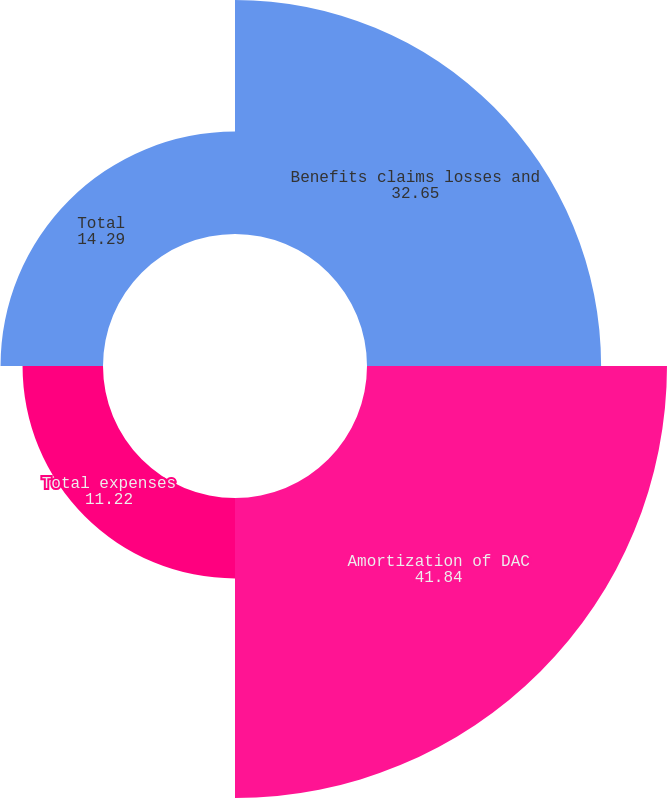Convert chart to OTSL. <chart><loc_0><loc_0><loc_500><loc_500><pie_chart><fcel>Benefits claims losses and<fcel>Amortization of DAC<fcel>Total expenses<fcel>Total<nl><fcel>32.65%<fcel>41.84%<fcel>11.22%<fcel>14.29%<nl></chart> 